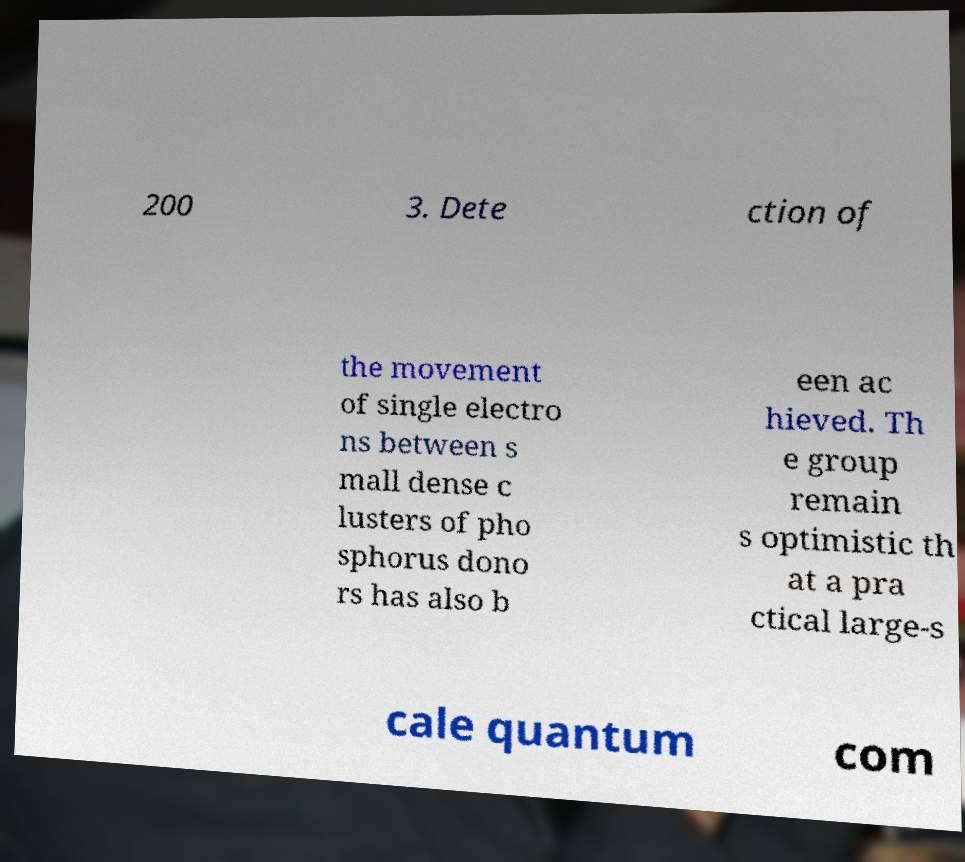What messages or text are displayed in this image? I need them in a readable, typed format. 200 3. Dete ction of the movement of single electro ns between s mall dense c lusters of pho sphorus dono rs has also b een ac hieved. Th e group remain s optimistic th at a pra ctical large-s cale quantum com 